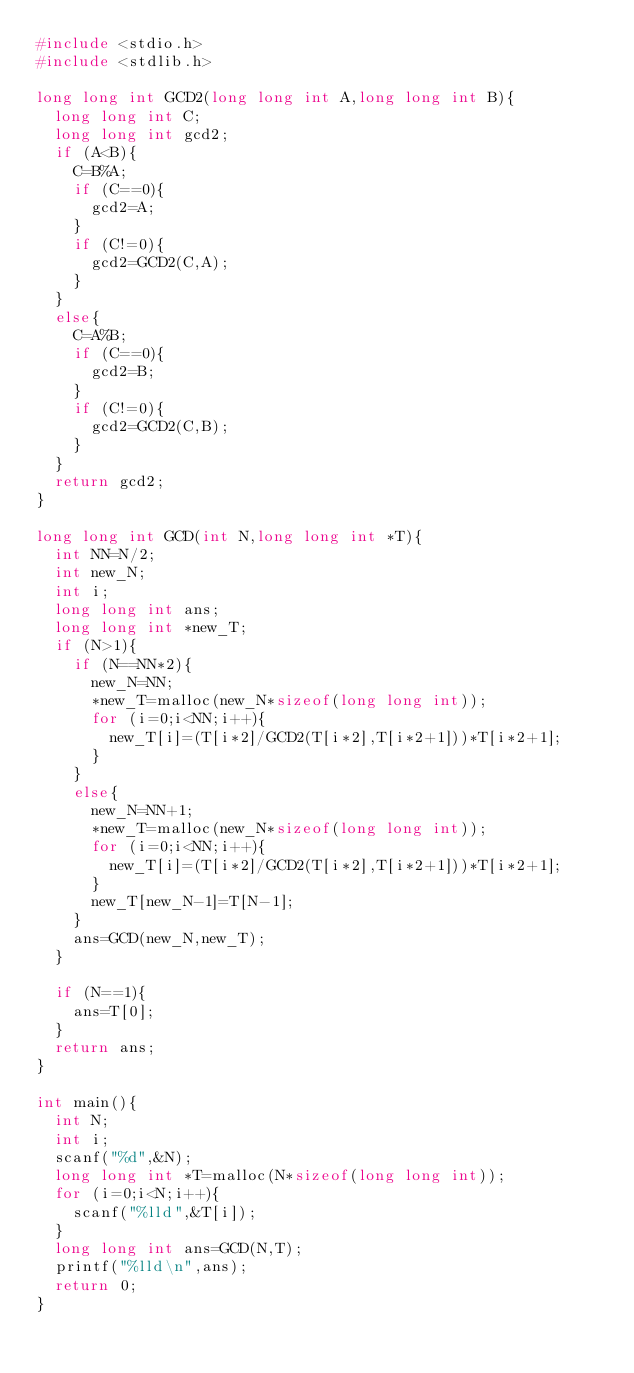Convert code to text. <code><loc_0><loc_0><loc_500><loc_500><_C_>#include <stdio.h>
#include <stdlib.h>

long long int GCD2(long long int A,long long int B){
	long long int C;
	long long int gcd2;
	if (A<B){
		C=B%A;
		if (C==0){
			gcd2=A;
		}
		if (C!=0){
			gcd2=GCD2(C,A);
		}
	}
	else{
		C=A%B;
		if (C==0){
			gcd2=B;
		}
		if (C!=0){
			gcd2=GCD2(C,B);
		}
	}
	return gcd2;
}

long long int GCD(int N,long long int *T){
	int NN=N/2;
	int new_N;
	int i;
	long long int ans;
	long long int *new_T;
	if (N>1){
		if (N==NN*2){
			new_N=NN;
			*new_T=malloc(new_N*sizeof(long long int));
			for (i=0;i<NN;i++){
				new_T[i]=(T[i*2]/GCD2(T[i*2],T[i*2+1]))*T[i*2+1];
			}
		}
		else{
			new_N=NN+1;
			*new_T=malloc(new_N*sizeof(long long int));
			for (i=0;i<NN;i++){
				new_T[i]=(T[i*2]/GCD2(T[i*2],T[i*2+1]))*T[i*2+1];
			}
			new_T[new_N-1]=T[N-1];
		}
		ans=GCD(new_N,new_T);
	}

	if (N==1){
		ans=T[0];
	}
	return ans;
}

int main(){
	int N;
	int i;
	scanf("%d",&N);
	long long int *T=malloc(N*sizeof(long long int));
	for (i=0;i<N;i++){
		scanf("%lld",&T[i]);
	}
	long long int ans=GCD(N,T);
	printf("%lld\n",ans);
	return 0;
}
</code> 